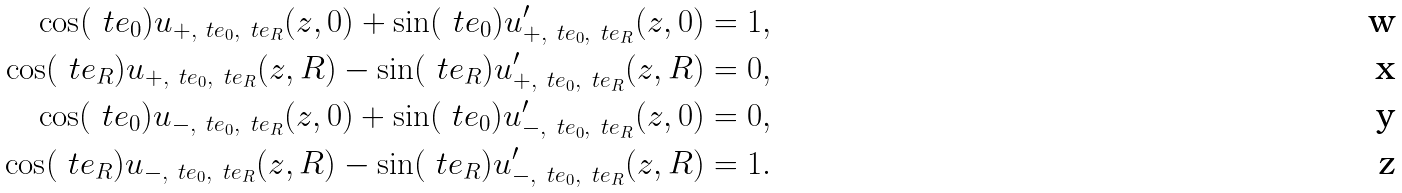<formula> <loc_0><loc_0><loc_500><loc_500>\cos ( \ t e _ { 0 } ) u _ { + , \ t e _ { 0 } , \ t e _ { R } } ( z , 0 ) + \sin ( \ t e _ { 0 } ) u _ { + , \ t e _ { 0 } , \ t e _ { R } } ^ { \prime } ( z , 0 ) & = 1 , \\ \cos ( \ t e _ { R } ) u _ { + , \ t e _ { 0 } , \ t e _ { R } } ( z , R ) - \sin ( \ t e _ { R } ) u _ { + , \ t e _ { 0 } , \ t e _ { R } } ^ { \prime } ( z , R ) & = 0 , \\ \cos ( \ t e _ { 0 } ) u _ { - , \ t e _ { 0 } , \ t e _ { R } } ( z , 0 ) + \sin ( \ t e _ { 0 } ) u _ { - , \ t e _ { 0 } , \ t e _ { R } } ^ { \prime } ( z , 0 ) & = 0 , \\ \cos ( \ t e _ { R } ) u _ { - , \ t e _ { 0 } , \ t e _ { R } } ( z , R ) - \sin ( \ t e _ { R } ) u _ { - , \ t e _ { 0 } , \ t e _ { R } } ^ { \prime } ( z , R ) & = 1 .</formula> 